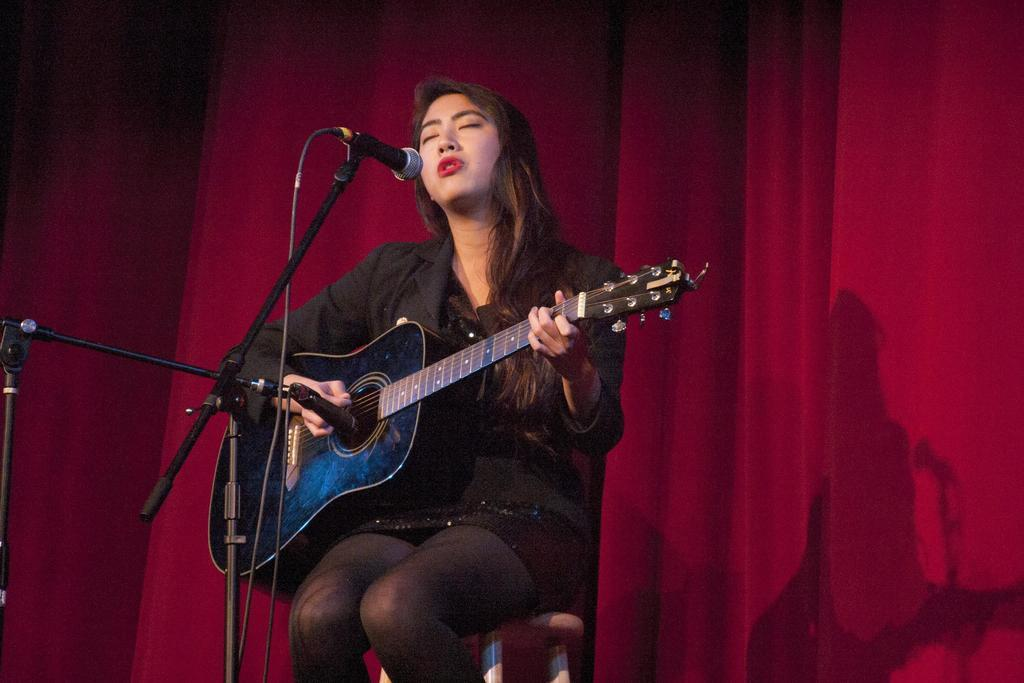Who is the main subject in the image? There is a woman in the image. What is the woman doing in the image? The woman is sitting on a chair and singing. What instrument is the woman holding in the image? The woman is holding a guitar in the image. What equipment is present for amplifying the woman's voice? There is a microphone with a stand in the image. What additional item can be seen in the image related to the setup? There is a cable in the image. What type of background element is present in the image? There is a curtain in the image. What type of grain is visible on the woman's shirt in the image? There is no grain visible on the woman's shirt in the image. What kind of crack can be seen on the microphone stand in the image? There is no crack visible on the microphone stand in the image. 